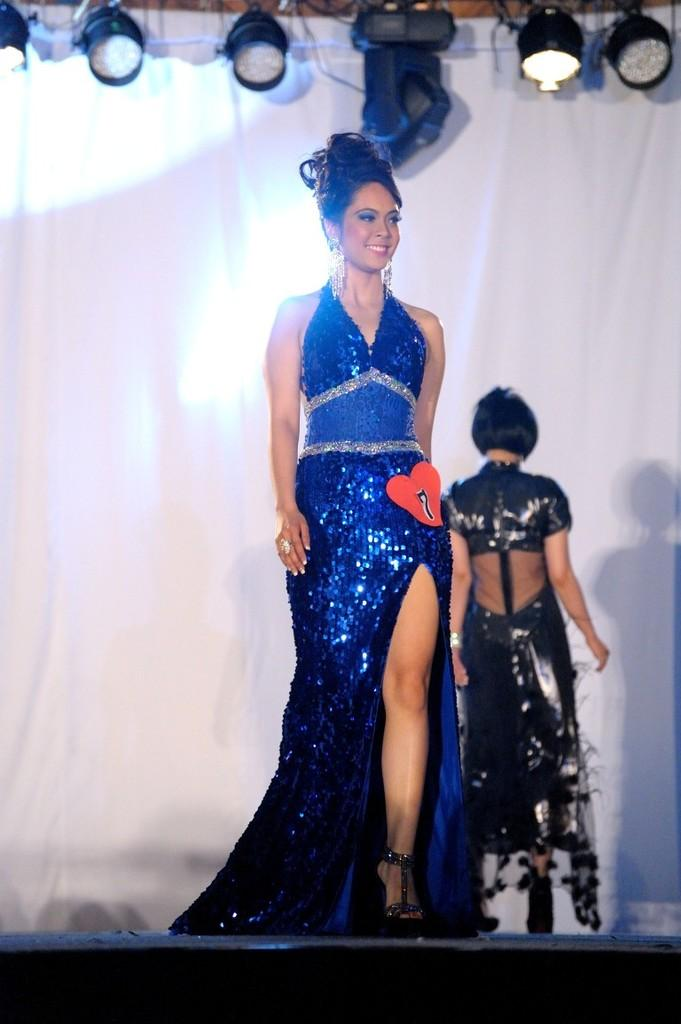What are the people in the image wearing? The people in the image are wearing different color dresses. What else can be seen in the image besides the people? There are lights visible in the image. What color is the cloth in the image? The cloth in the image is white. What type of bean is being served on the table in the image? There is no table or bean present in the image. Is there a maid in the image who is regretting something? There is no maid or indication of regret in the image. 